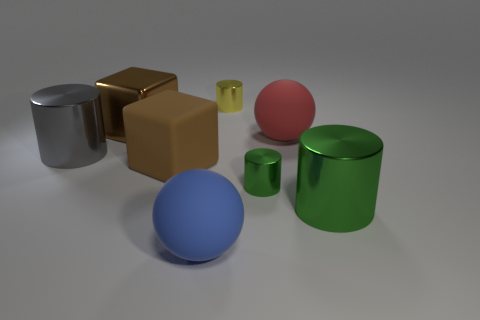What number of things are tiny shiny cylinders in front of the large gray cylinder or objects on the left side of the small yellow cylinder?
Provide a short and direct response. 5. There is a cylinder that is both behind the rubber block and in front of the big brown shiny object; how big is it?
Your answer should be very brief. Large. Do the tiny yellow thing and the thing in front of the big green thing have the same shape?
Your response must be concise. No. How many objects are small objects in front of the gray cylinder or metallic blocks?
Provide a short and direct response. 2. Does the blue ball have the same material as the big sphere that is on the right side of the small yellow thing?
Provide a succinct answer. Yes. What is the shape of the big metal thing that is to the right of the rubber object on the right side of the blue matte object?
Your answer should be very brief. Cylinder. Is the color of the big rubber block the same as the small metal thing that is behind the small green thing?
Your answer should be compact. No. Is there any other thing that has the same material as the large gray cylinder?
Give a very brief answer. Yes. What shape is the gray thing?
Ensure brevity in your answer.  Cylinder. What size is the matte object in front of the big cube that is on the right side of the brown metal thing?
Your response must be concise. Large. 